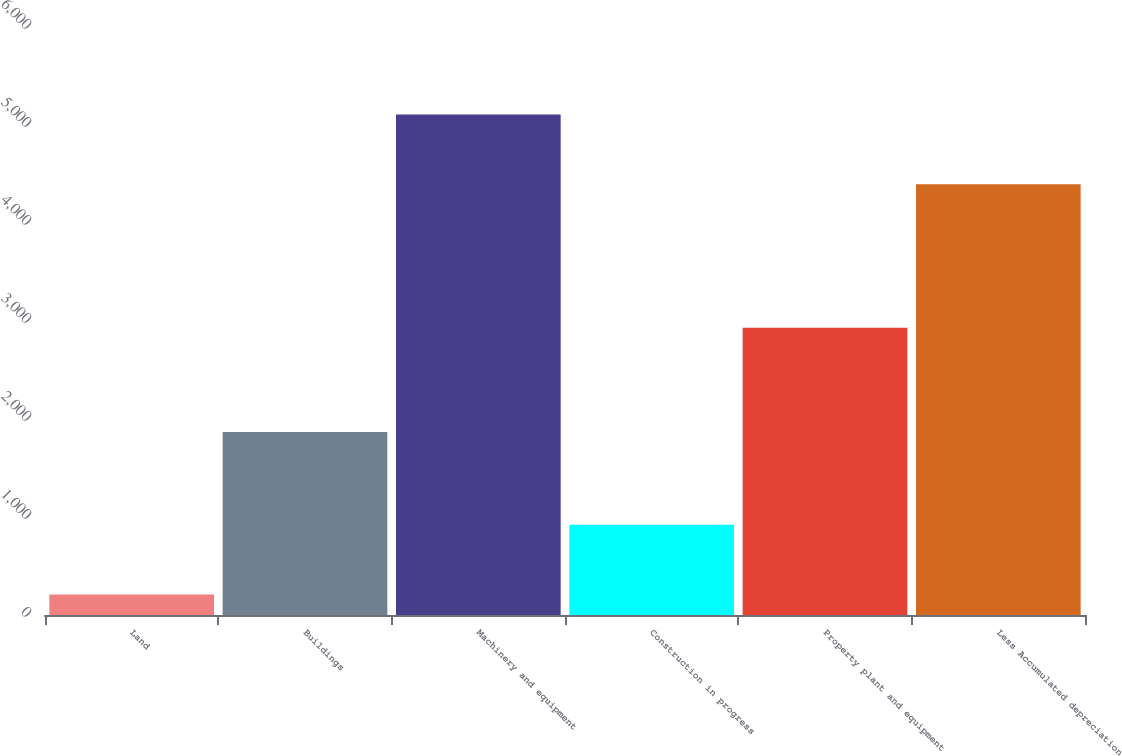Convert chart to OTSL. <chart><loc_0><loc_0><loc_500><loc_500><bar_chart><fcel>Land<fcel>Buildings<fcel>Machinery and equipment<fcel>Construction in progress<fcel>Property plant and equipment<fcel>Less Accumulated depreciation<nl><fcel>210<fcel>1867<fcel>5107.7<fcel>921.7<fcel>2931<fcel>4396<nl></chart> 